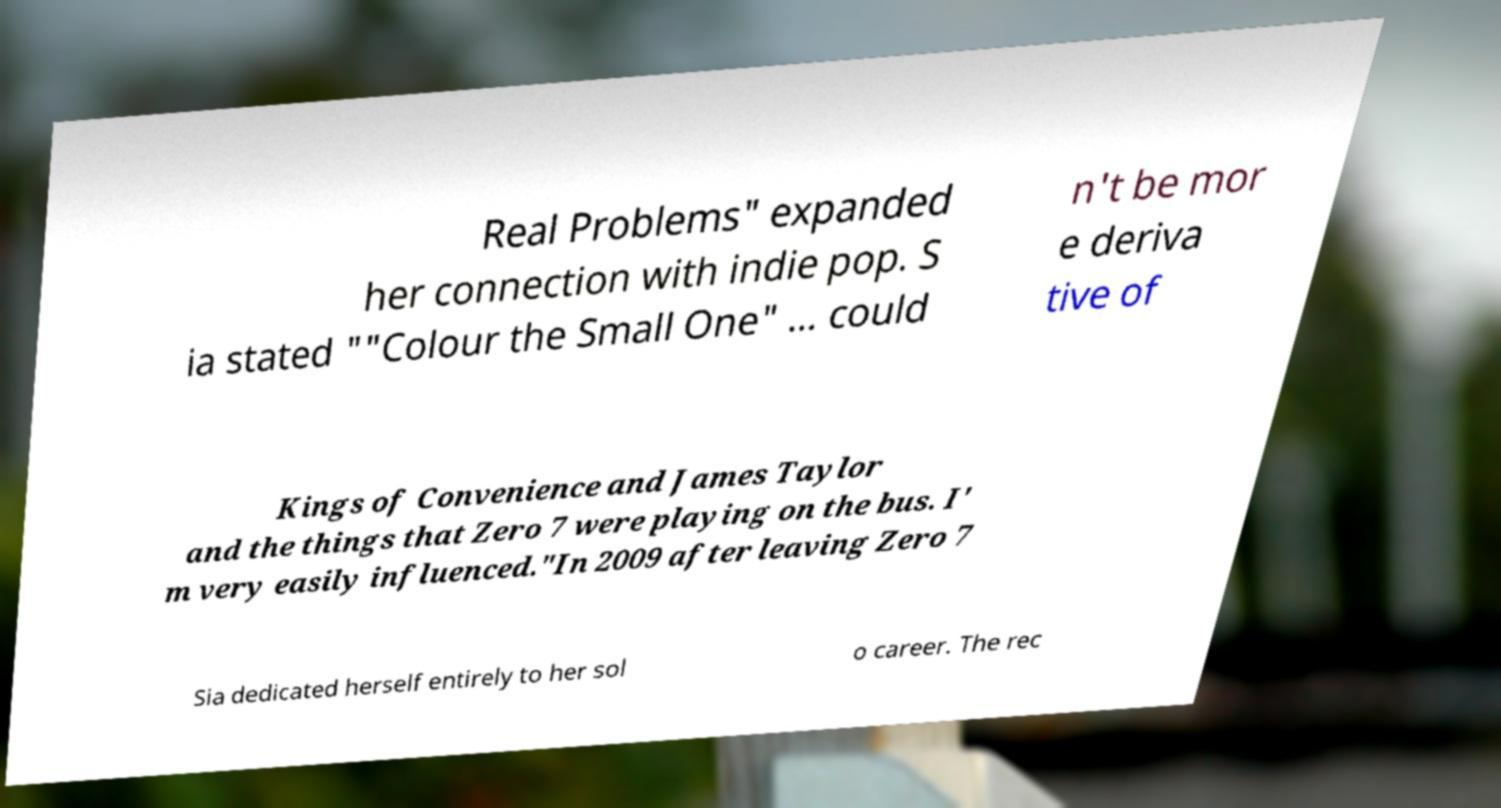There's text embedded in this image that I need extracted. Can you transcribe it verbatim? Real Problems" expanded her connection with indie pop. S ia stated ""Colour the Small One" ... could n't be mor e deriva tive of Kings of Convenience and James Taylor and the things that Zero 7 were playing on the bus. I' m very easily influenced."In 2009 after leaving Zero 7 Sia dedicated herself entirely to her sol o career. The rec 